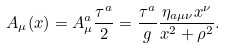Convert formula to latex. <formula><loc_0><loc_0><loc_500><loc_500>A _ { \mu } ( x ) = A ^ { a } _ { \mu } \frac { \tau ^ { a } } { 2 } = \frac { \tau ^ { a } } { g } \frac { \eta _ { a \mu \nu } x ^ { \nu } } { x ^ { 2 } + \rho ^ { 2 } } .</formula> 